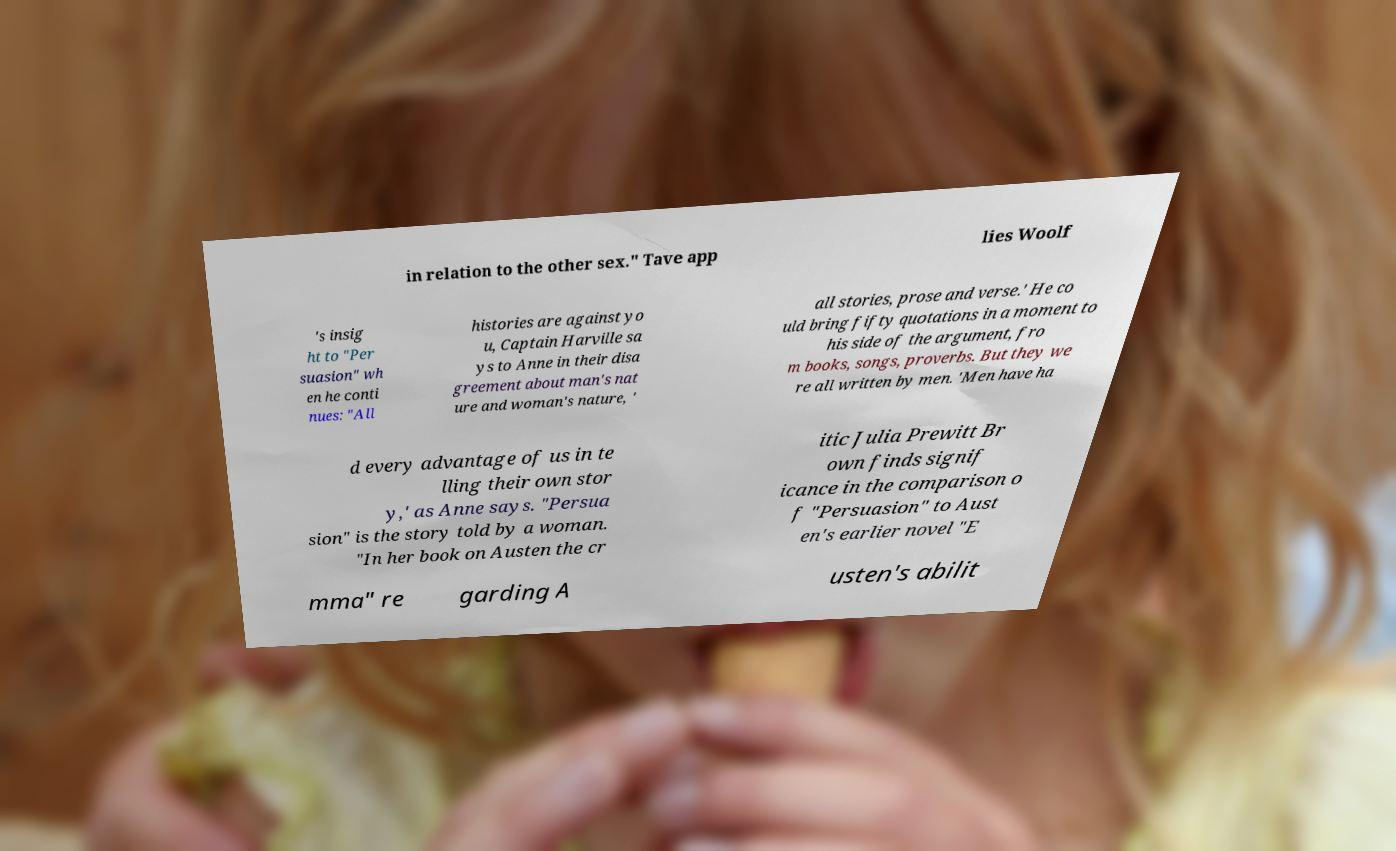I need the written content from this picture converted into text. Can you do that? in relation to the other sex." Tave app lies Woolf 's insig ht to "Per suasion" wh en he conti nues: "All histories are against yo u, Captain Harville sa ys to Anne in their disa greement about man's nat ure and woman's nature, ' all stories, prose and verse.' He co uld bring fifty quotations in a moment to his side of the argument, fro m books, songs, proverbs. But they we re all written by men. 'Men have ha d every advantage of us in te lling their own stor y,' as Anne says. "Persua sion" is the story told by a woman. "In her book on Austen the cr itic Julia Prewitt Br own finds signif icance in the comparison o f "Persuasion" to Aust en's earlier novel "E mma" re garding A usten's abilit 